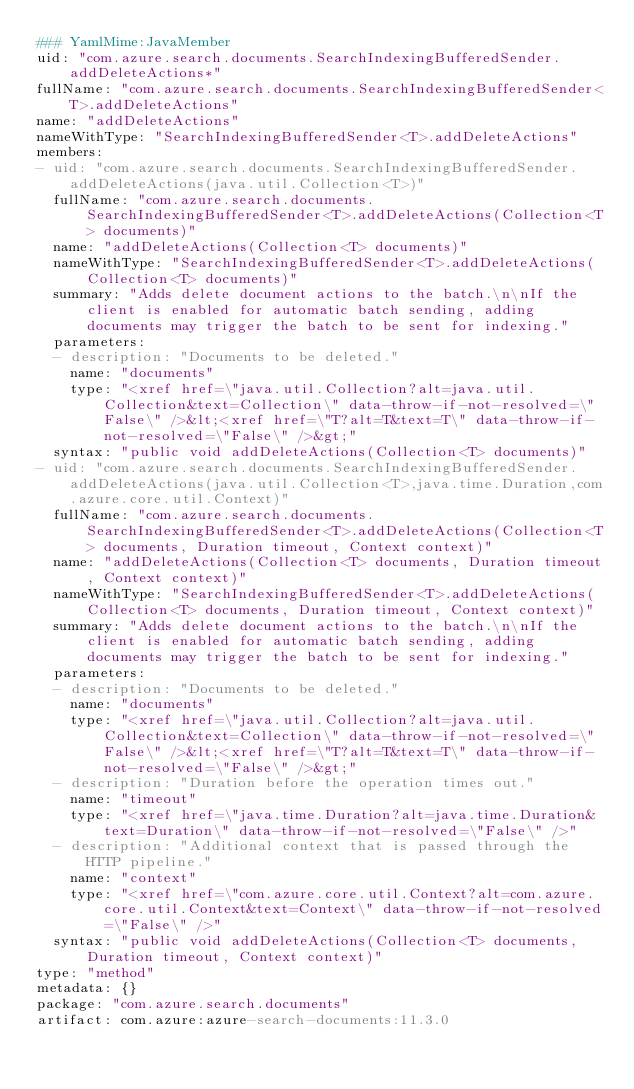<code> <loc_0><loc_0><loc_500><loc_500><_YAML_>### YamlMime:JavaMember
uid: "com.azure.search.documents.SearchIndexingBufferedSender.addDeleteActions*"
fullName: "com.azure.search.documents.SearchIndexingBufferedSender<T>.addDeleteActions"
name: "addDeleteActions"
nameWithType: "SearchIndexingBufferedSender<T>.addDeleteActions"
members:
- uid: "com.azure.search.documents.SearchIndexingBufferedSender.addDeleteActions(java.util.Collection<T>)"
  fullName: "com.azure.search.documents.SearchIndexingBufferedSender<T>.addDeleteActions(Collection<T> documents)"
  name: "addDeleteActions(Collection<T> documents)"
  nameWithType: "SearchIndexingBufferedSender<T>.addDeleteActions(Collection<T> documents)"
  summary: "Adds delete document actions to the batch.\n\nIf the client is enabled for automatic batch sending, adding documents may trigger the batch to be sent for indexing."
  parameters:
  - description: "Documents to be deleted."
    name: "documents"
    type: "<xref href=\"java.util.Collection?alt=java.util.Collection&text=Collection\" data-throw-if-not-resolved=\"False\" />&lt;<xref href=\"T?alt=T&text=T\" data-throw-if-not-resolved=\"False\" />&gt;"
  syntax: "public void addDeleteActions(Collection<T> documents)"
- uid: "com.azure.search.documents.SearchIndexingBufferedSender.addDeleteActions(java.util.Collection<T>,java.time.Duration,com.azure.core.util.Context)"
  fullName: "com.azure.search.documents.SearchIndexingBufferedSender<T>.addDeleteActions(Collection<T> documents, Duration timeout, Context context)"
  name: "addDeleteActions(Collection<T> documents, Duration timeout, Context context)"
  nameWithType: "SearchIndexingBufferedSender<T>.addDeleteActions(Collection<T> documents, Duration timeout, Context context)"
  summary: "Adds delete document actions to the batch.\n\nIf the client is enabled for automatic batch sending, adding documents may trigger the batch to be sent for indexing."
  parameters:
  - description: "Documents to be deleted."
    name: "documents"
    type: "<xref href=\"java.util.Collection?alt=java.util.Collection&text=Collection\" data-throw-if-not-resolved=\"False\" />&lt;<xref href=\"T?alt=T&text=T\" data-throw-if-not-resolved=\"False\" />&gt;"
  - description: "Duration before the operation times out."
    name: "timeout"
    type: "<xref href=\"java.time.Duration?alt=java.time.Duration&text=Duration\" data-throw-if-not-resolved=\"False\" />"
  - description: "Additional context that is passed through the HTTP pipeline."
    name: "context"
    type: "<xref href=\"com.azure.core.util.Context?alt=com.azure.core.util.Context&text=Context\" data-throw-if-not-resolved=\"False\" />"
  syntax: "public void addDeleteActions(Collection<T> documents, Duration timeout, Context context)"
type: "method"
metadata: {}
package: "com.azure.search.documents"
artifact: com.azure:azure-search-documents:11.3.0
</code> 